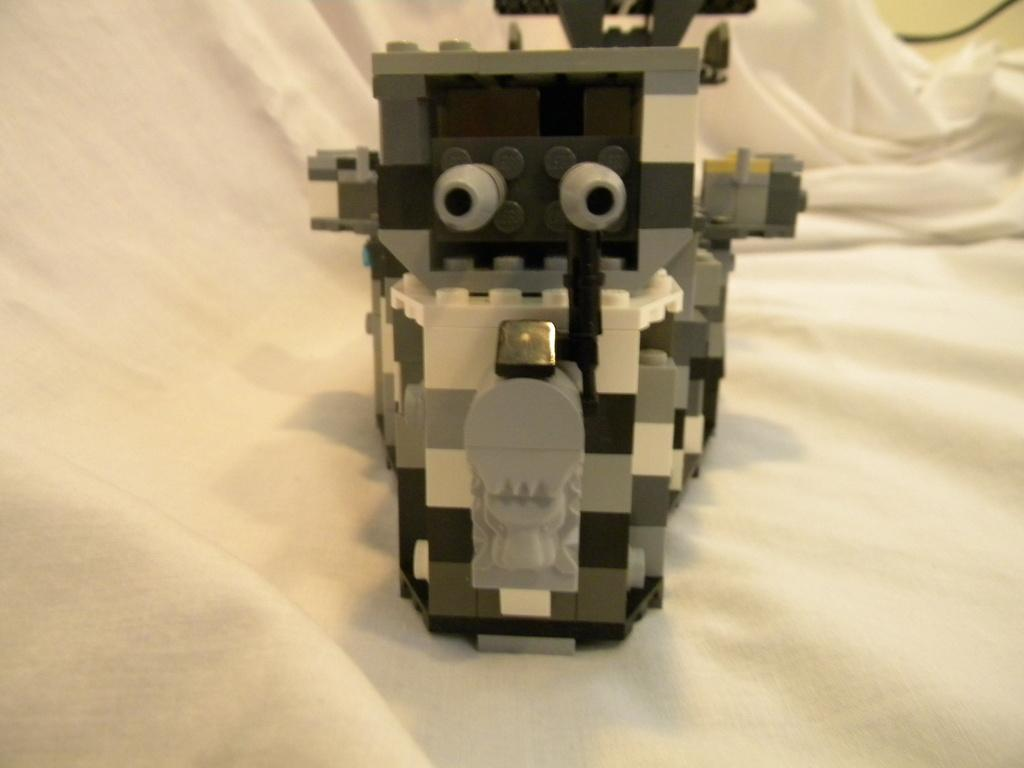What is the main object in the image? There is a toy in the image. Can you describe the colors of the toy? The toy has white, grey, and black colors. What is the background of the image? There is a white background in the image, which might be a sheet or a blanket. What is the chance of winning a prize in the scene depicted in the image? There is no scene or prize mentioned in the image; it only features a toy on a white background. 